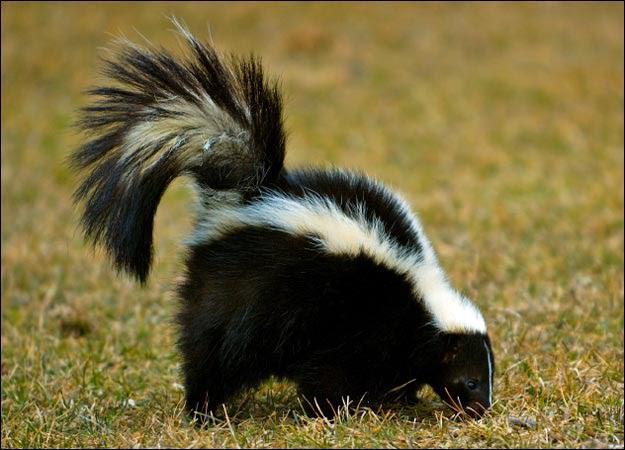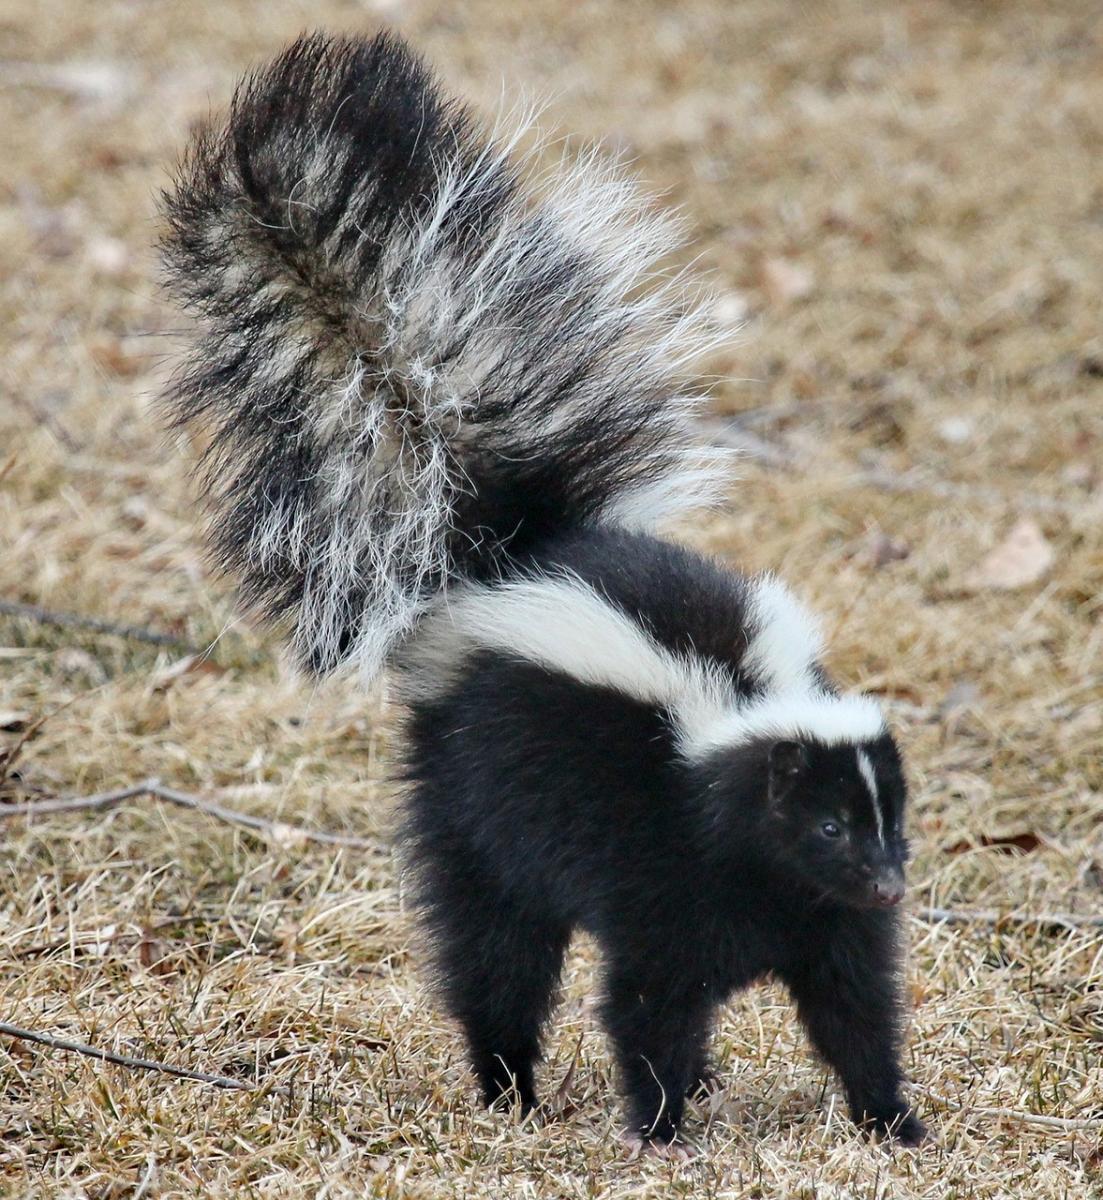The first image is the image on the left, the second image is the image on the right. Evaluate the accuracy of this statement regarding the images: "Each image contains one skunk with its tail raised, and at least one image features a skunk with its body, tail and head facing directly forward.". Is it true? Answer yes or no. No. The first image is the image on the left, the second image is the image on the right. Evaluate the accuracy of this statement regarding the images: "Both skunks are on the ground.". Is it true? Answer yes or no. Yes. 